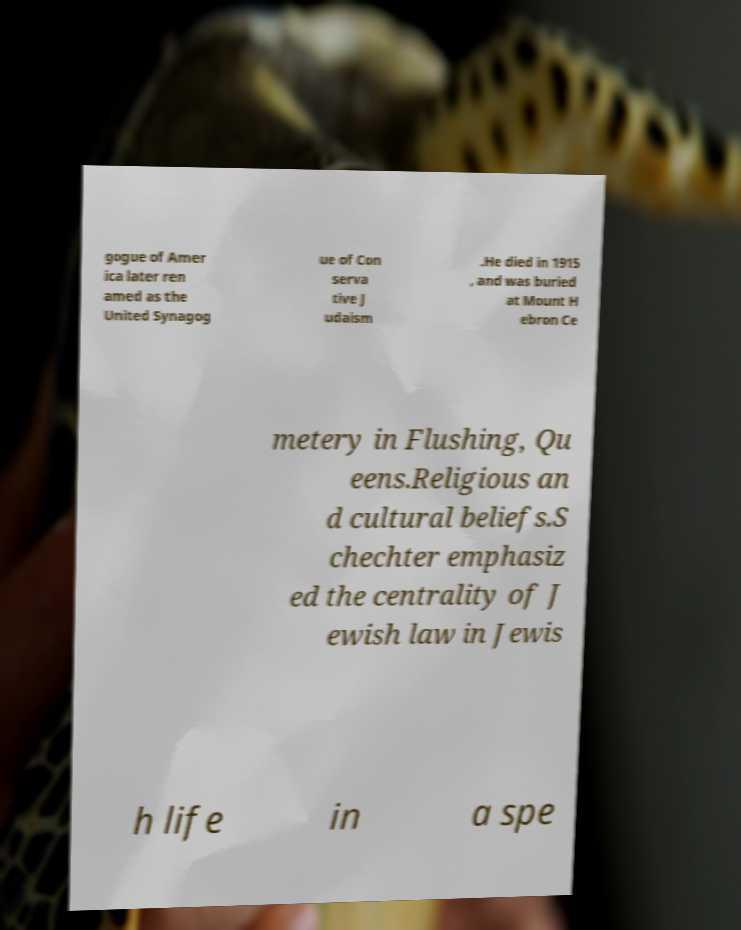Can you read and provide the text displayed in the image?This photo seems to have some interesting text. Can you extract and type it out for me? gogue of Amer ica later ren amed as the United Synagog ue of Con serva tive J udaism .He died in 1915 , and was buried at Mount H ebron Ce metery in Flushing, Qu eens.Religious an d cultural beliefs.S chechter emphasiz ed the centrality of J ewish law in Jewis h life in a spe 